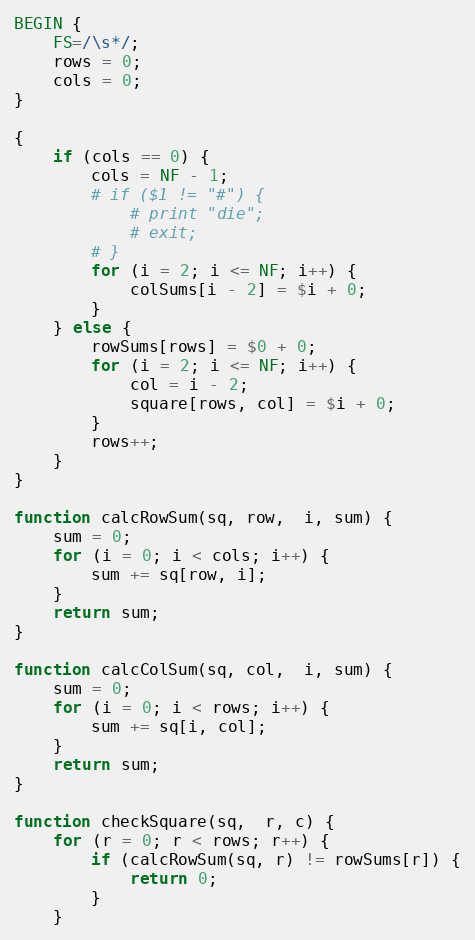<code> <loc_0><loc_0><loc_500><loc_500><_Awk_>BEGIN {
	FS=/\s*/;
	rows = 0;
	cols = 0;
}

{
	if (cols == 0) {
		cols = NF - 1;
		# if ($1 != "#") {
			# print "die";
			# exit;
		# }
		for (i = 2; i <= NF; i++) {
			colSums[i - 2] = $i + 0;
		}
	} else {
		rowSums[rows] = $0 + 0;
		for (i = 2; i <= NF; i++) {
			col = i - 2;
			square[rows, col] = $i + 0;
		}
		rows++;
	}
}

function calcRowSum(sq, row,  i, sum) {
	sum = 0;
	for (i = 0; i < cols; i++) {
		sum += sq[row, i];
	}
	return sum;
}

function calcColSum(sq, col,  i, sum) {
	sum = 0;
	for (i = 0; i < rows; i++) {
		sum += sq[i, col];
	}
	return sum;
}

function checkSquare(sq,  r, c) {
	for (r = 0; r < rows; r++) {
		if (calcRowSum(sq, r) != rowSums[r]) {
			return 0;
		}
	}</code> 